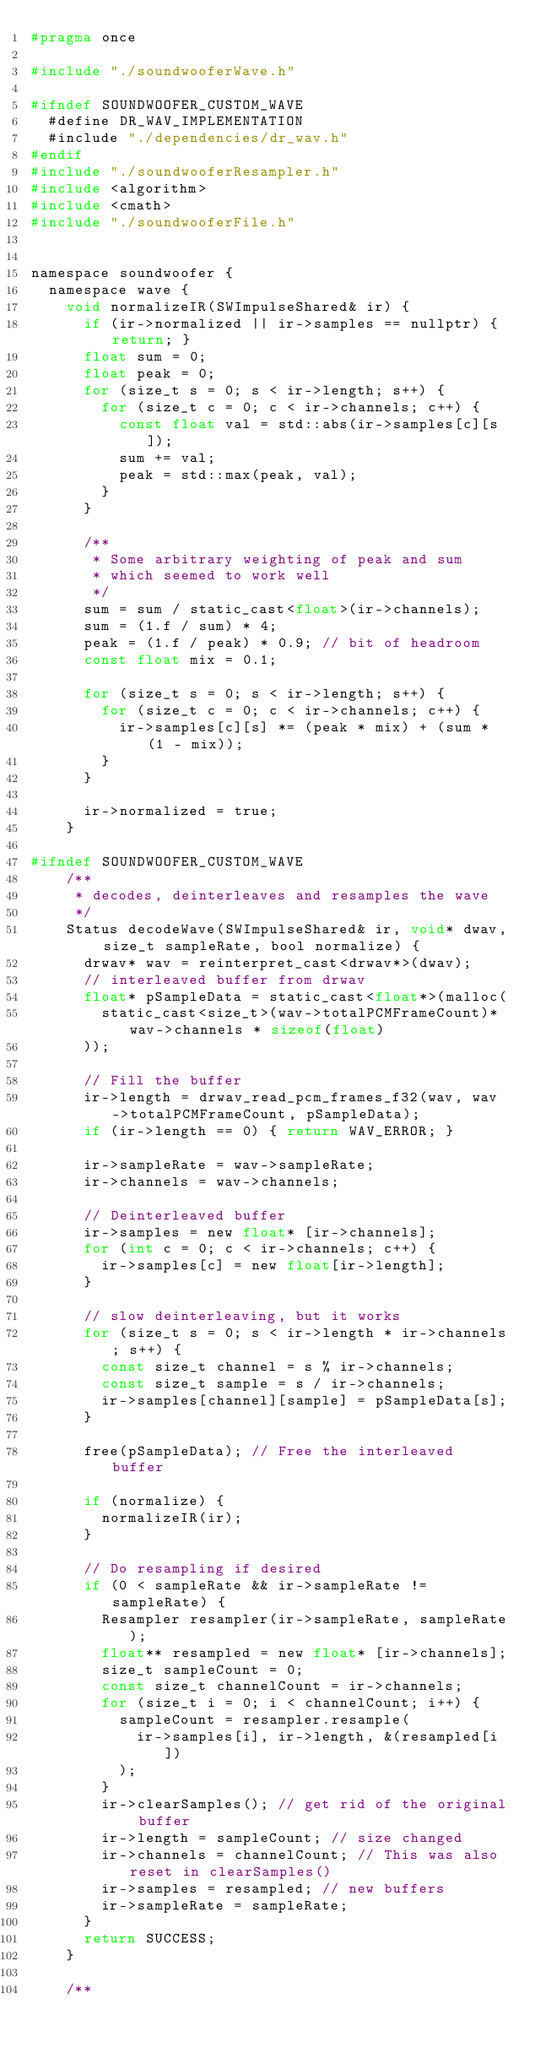Convert code to text. <code><loc_0><loc_0><loc_500><loc_500><_C_>#pragma once

#include "./soundwooferWave.h"

#ifndef SOUNDWOOFER_CUSTOM_WAVE
  #define DR_WAV_IMPLEMENTATION
  #include "./dependencies/dr_wav.h"
#endif
#include "./soundwooferResampler.h"
#include <algorithm>
#include <cmath>
#include "./soundwooferFile.h"


namespace soundwoofer {
  namespace wave {
    void normalizeIR(SWImpulseShared& ir) {
      if (ir->normalized || ir->samples == nullptr) { return; }
      float sum = 0;
      float peak = 0;
      for (size_t s = 0; s < ir->length; s++) {
        for (size_t c = 0; c < ir->channels; c++) {
          const float val = std::abs(ir->samples[c][s]);
          sum += val;
          peak = std::max(peak, val);
        }
      }

      /**
       * Some arbitrary weighting of peak and sum
       * which seemed to work well
       */
      sum = sum / static_cast<float>(ir->channels);
      sum = (1.f / sum) * 4;
      peak = (1.f / peak) * 0.9; // bit of headroom
      const float mix = 0.1;

      for (size_t s = 0; s < ir->length; s++) {
        for (size_t c = 0; c < ir->channels; c++) {
          ir->samples[c][s] *= (peak * mix) + (sum * (1 - mix));
        }
      }

      ir->normalized = true;
    }

#ifndef SOUNDWOOFER_CUSTOM_WAVE
    /**
     * decodes, deinterleaves and resamples the wave
     */
    Status decodeWave(SWImpulseShared& ir, void* dwav, size_t sampleRate, bool normalize) {
      drwav* wav = reinterpret_cast<drwav*>(dwav);
      // interleaved buffer from drwav
      float* pSampleData = static_cast<float*>(malloc(
        static_cast<size_t>(wav->totalPCMFrameCount)* wav->channels * sizeof(float)
      ));

      // Fill the buffer
      ir->length = drwav_read_pcm_frames_f32(wav, wav->totalPCMFrameCount, pSampleData);
      if (ir->length == 0) { return WAV_ERROR; }

      ir->sampleRate = wav->sampleRate;
      ir->channels = wav->channels;

      // Deinterleaved buffer
      ir->samples = new float* [ir->channels];
      for (int c = 0; c < ir->channels; c++) {
        ir->samples[c] = new float[ir->length];
      }

      // slow deinterleaving, but it works
      for (size_t s = 0; s < ir->length * ir->channels; s++) {
        const size_t channel = s % ir->channels;
        const size_t sample = s / ir->channels;
        ir->samples[channel][sample] = pSampleData[s];
      }

      free(pSampleData); // Free the interleaved buffer

      if (normalize) {
        normalizeIR(ir);
      }

      // Do resampling if desired
      if (0 < sampleRate && ir->sampleRate != sampleRate) {
        Resampler resampler(ir->sampleRate, sampleRate);
        float** resampled = new float* [ir->channels];
        size_t sampleCount = 0;
        const size_t channelCount = ir->channels;
        for (size_t i = 0; i < channelCount; i++) {
          sampleCount = resampler.resample(
            ir->samples[i], ir->length, &(resampled[i])
          );
        }
        ir->clearSamples(); // get rid of the original buffer
        ir->length = sampleCount; // size changed
        ir->channels = channelCount; // This was also reset in clearSamples()
        ir->samples = resampled; // new buffers
        ir->sampleRate = sampleRate;
      }
      return SUCCESS;
    }

    /**</code> 